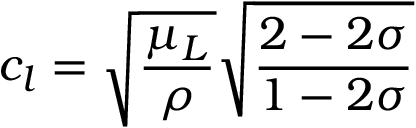Convert formula to latex. <formula><loc_0><loc_0><loc_500><loc_500>c _ { l } = \sqrt { \frac { \mu _ { L } } { \rho } } \sqrt { \frac { 2 - 2 \sigma } { 1 - 2 \sigma } }</formula> 